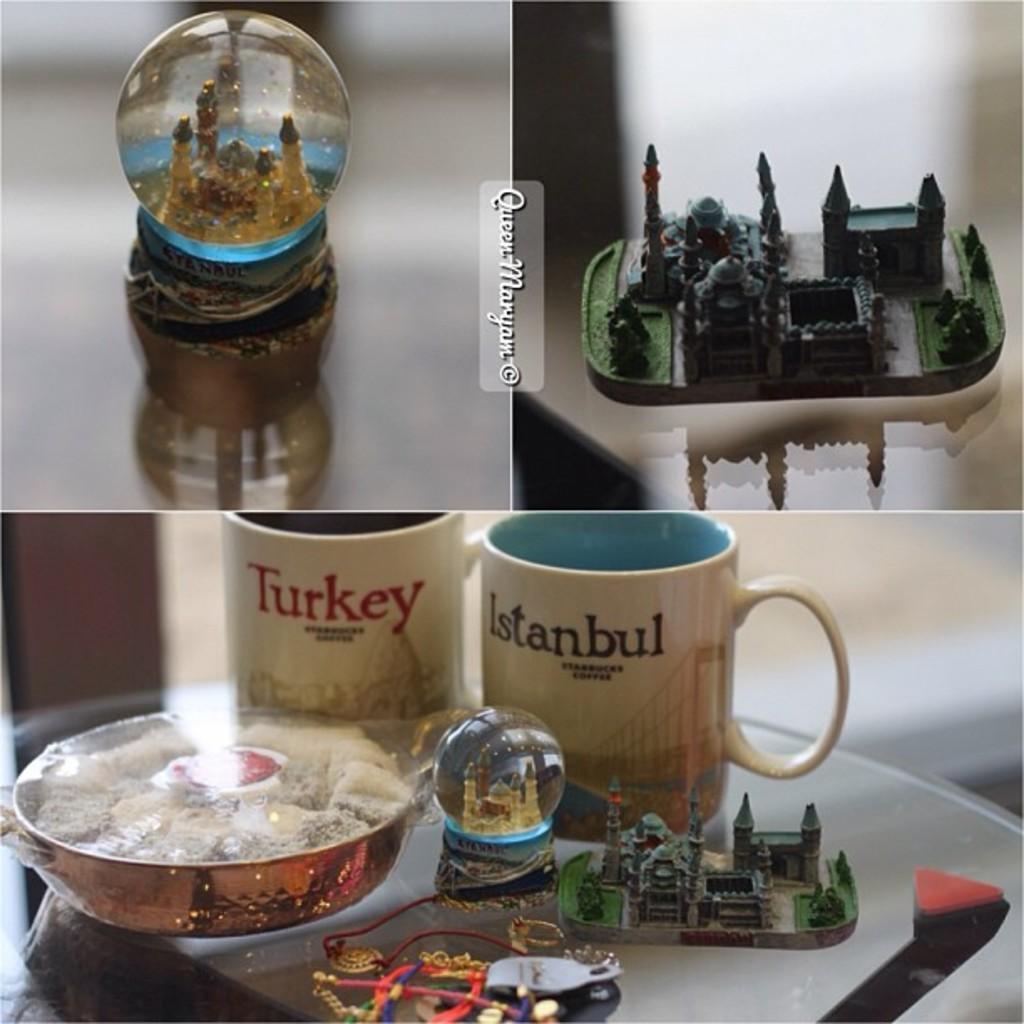Could you give a brief overview of what you see in this image? Here this is a collage image and at the top right we can see something present and at the top left we can see something present and at the bottom we can see cups present and a plate and some other things placed on a table 